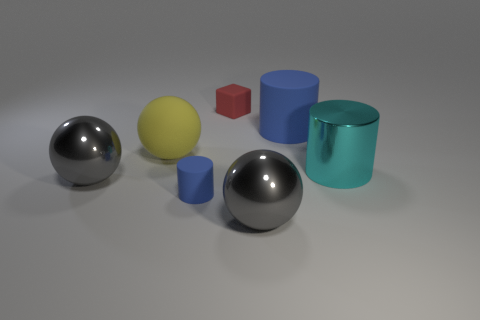Is there a cylinder that has the same size as the yellow rubber object?
Provide a short and direct response. Yes. The big thing that is both on the right side of the large yellow object and in front of the big cyan cylinder is made of what material?
Your answer should be very brief. Metal. How many metallic objects are small cylinders or small yellow blocks?
Offer a very short reply. 0. There is a big yellow thing that is made of the same material as the red object; what is its shape?
Your response must be concise. Sphere. What number of rubber things are on the right side of the large yellow rubber thing and to the left of the red block?
Keep it short and to the point. 1. Is there any other thing that has the same shape as the red object?
Provide a short and direct response. No. There is a blue rubber thing that is right of the red block; what size is it?
Keep it short and to the point. Large. How many other things are there of the same color as the tiny matte cylinder?
Give a very brief answer. 1. What material is the blue thing that is to the right of the gray metallic ball on the right side of the tiny rubber cube?
Offer a very short reply. Rubber. Does the small rubber object on the left side of the red block have the same color as the metallic cylinder?
Your answer should be compact. No. 